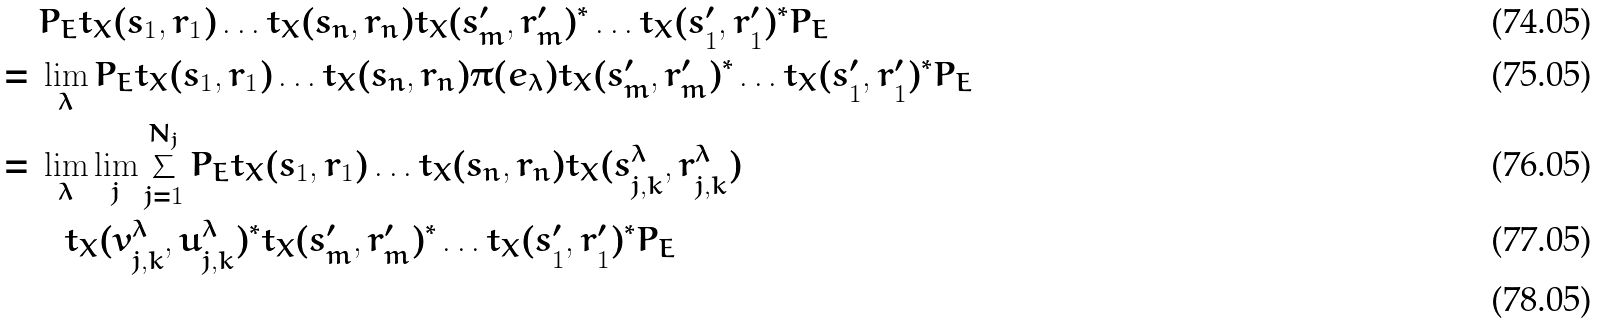Convert formula to latex. <formula><loc_0><loc_0><loc_500><loc_500>& \ P _ { E } t _ { X } ( s _ { 1 } , r _ { 1 } ) \dots t _ { X } ( s _ { n } , r _ { n } ) t _ { X } ( s ^ { \prime } _ { m } , r ^ { \prime } _ { m } ) ^ { * } \dots t _ { X } ( s ^ { \prime } _ { 1 } , r ^ { \prime } _ { 1 } ) ^ { * } P _ { E } \\ = & \ \lim _ { \lambda } P _ { E } t _ { X } ( s _ { 1 } , r _ { 1 } ) \dots t _ { X } ( s _ { n } , r _ { n } ) \pi ( e _ { \lambda } ) t _ { X } ( s ^ { \prime } _ { m } , r ^ { \prime } _ { m } ) ^ { * } \dots t _ { X } ( s ^ { \prime } _ { 1 } , r ^ { \prime } _ { 1 } ) ^ { * } P _ { E } \\ = & \ \lim _ { \lambda } \lim _ { j } \sum _ { j = 1 } ^ { N _ { j } } P _ { E } t _ { X } ( s _ { 1 } , r _ { 1 } ) \dots t _ { X } ( s _ { n } , r _ { n } ) t _ { X } ( s ^ { \lambda } _ { j , k } , r ^ { \lambda } _ { j , k } ) \\ & \quad t _ { X } ( v ^ { \lambda } _ { j , k } , u ^ { \lambda } _ { j , k } ) ^ { * } t _ { X } ( s ^ { \prime } _ { m } , r ^ { \prime } _ { m } ) ^ { * } \dots t _ { X } ( s ^ { \prime } _ { 1 } , r ^ { \prime } _ { 1 } ) ^ { * } P _ { E } \\</formula> 